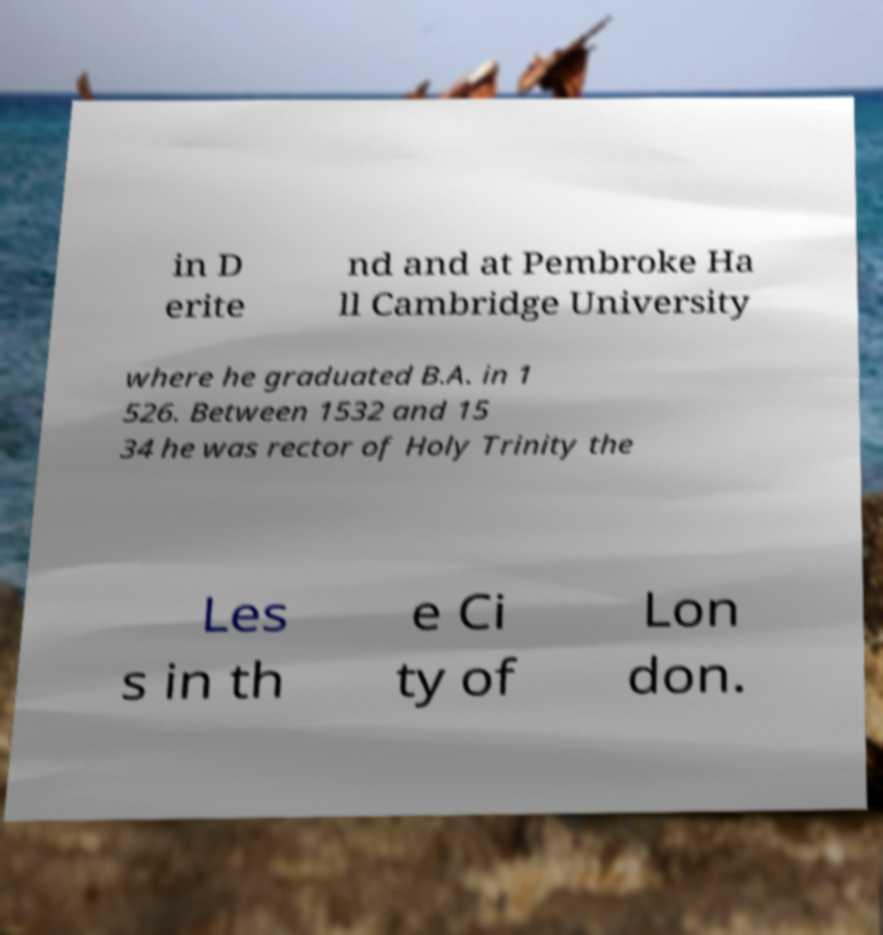Please read and relay the text visible in this image. What does it say? in D erite nd and at Pembroke Ha ll Cambridge University where he graduated B.A. in 1 526. Between 1532 and 15 34 he was rector of Holy Trinity the Les s in th e Ci ty of Lon don. 